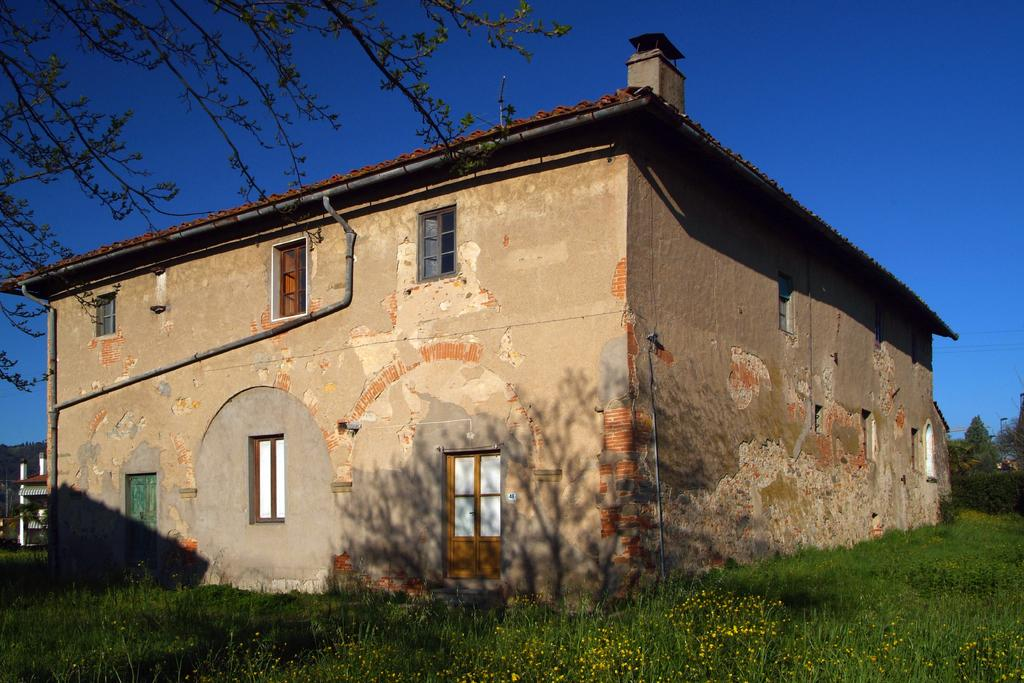What type of vegetation can be seen in the image? There is grass in the image. What type of structure is present in the image? There is a building with windows and doors in the image. Where are the trees located in the image? The trees are on the right side of the image. What type of cabbage is growing on the left side of the image? There is no cabbage present in the image; it only features grass, trees, and a building. 